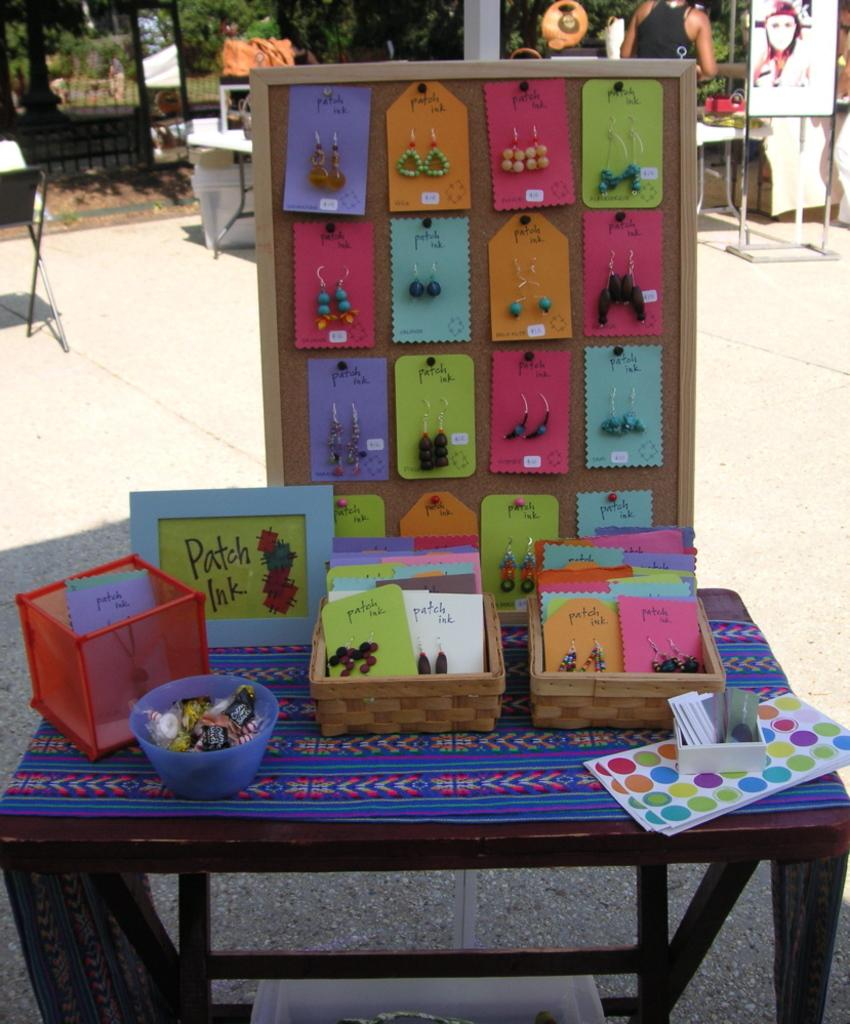What is the main object in the image? There is a table in the image. What is placed on the table? There are boxes on the table. What else can be seen in the image besides the table and boxes? There are accessories visible in the image. What can be seen in the background of the image? There are stalls, a person, and trees in the background of the image. What type of ornament is hanging from the machine in the image? There is no machine or ornament present in the image. What form does the person in the background of the image take? The person in the background of the image is a human figure, and it is not possible to describe their form in detail based on the image alone. 